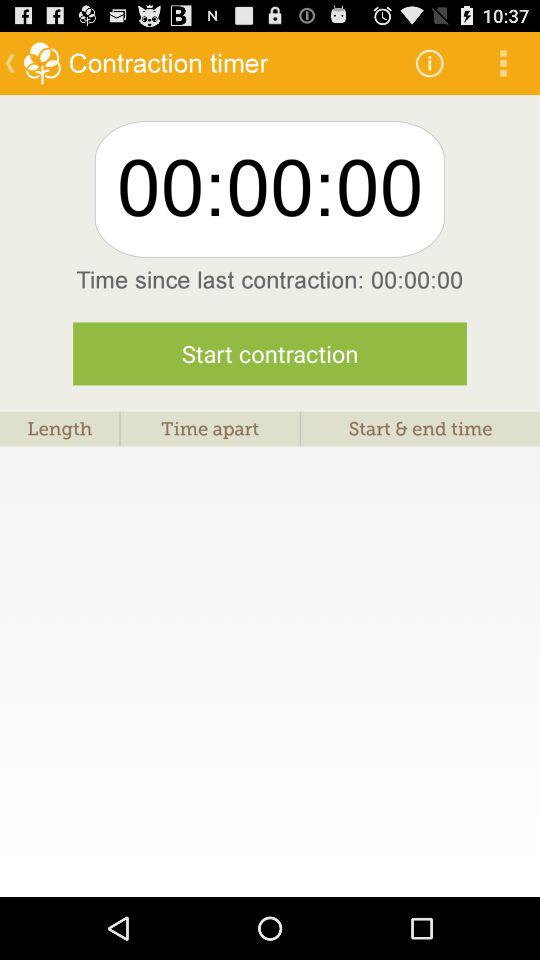How many seconds have elapsed since the last contraction?
Answer the question using a single word or phrase. 0 